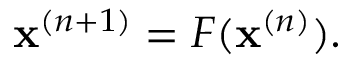Convert formula to latex. <formula><loc_0><loc_0><loc_500><loc_500>\begin{array} { r } { x ^ { ( n + 1 ) } = F ( x ^ { ( n ) } ) . } \end{array}</formula> 